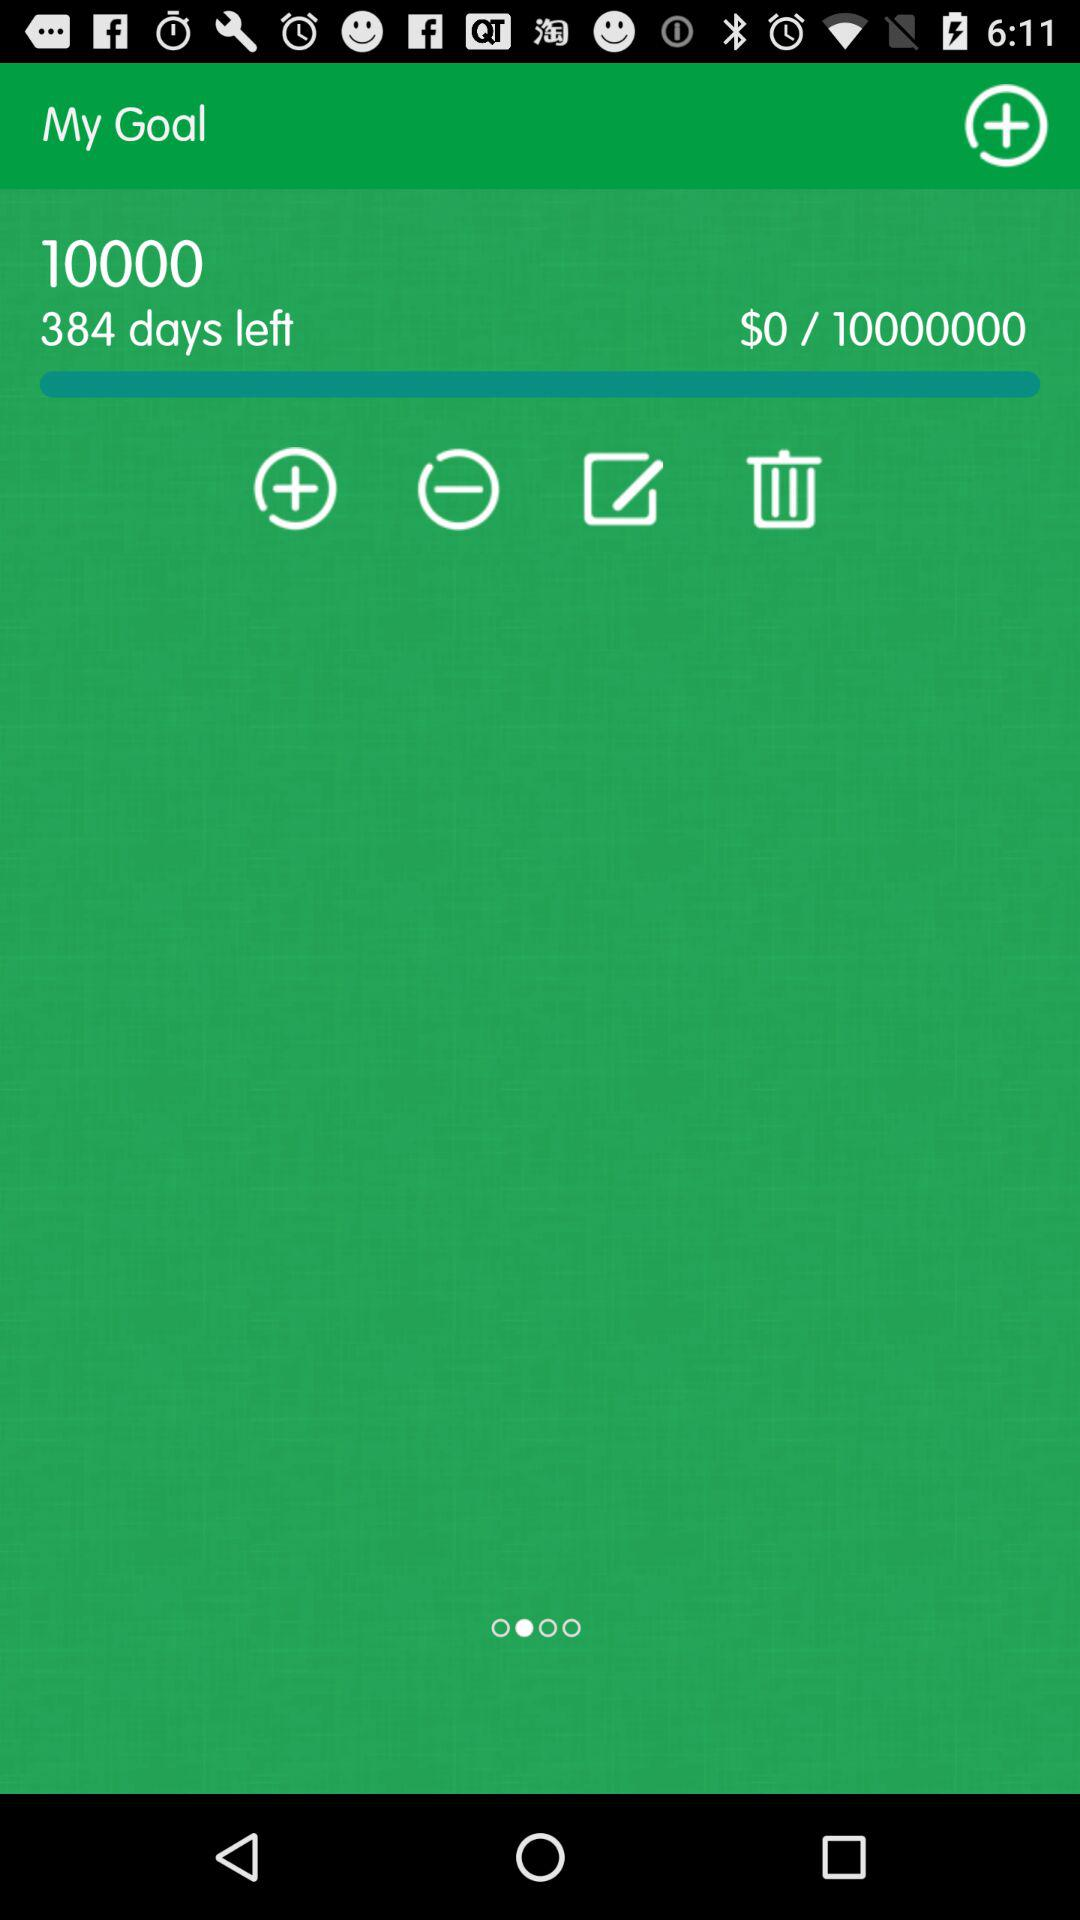How many days are left to reach the goal?
Answer the question using a single word or phrase. 384 